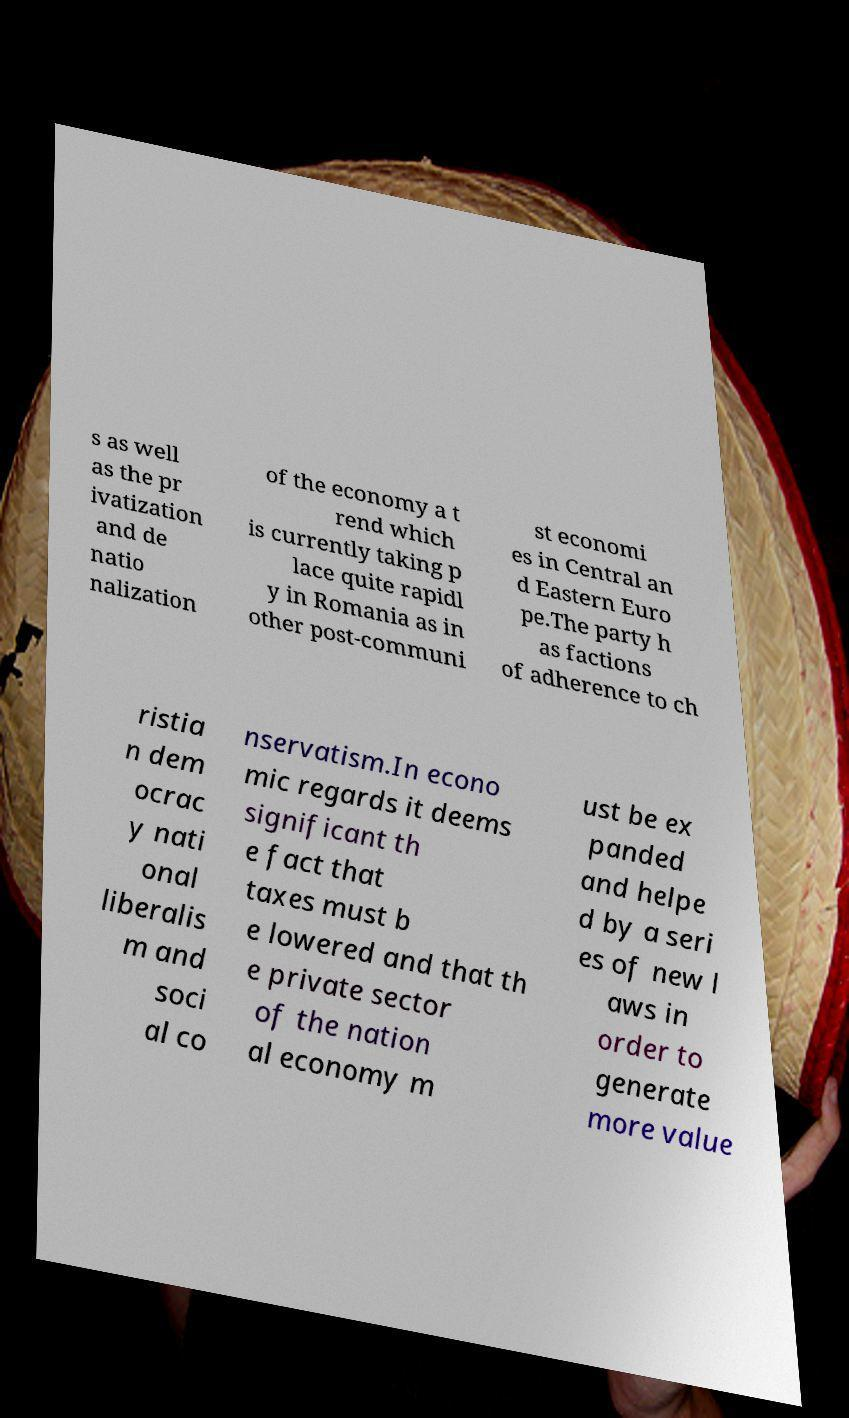Could you extract and type out the text from this image? s as well as the pr ivatization and de natio nalization of the economy a t rend which is currently taking p lace quite rapidl y in Romania as in other post-communi st economi es in Central an d Eastern Euro pe.The party h as factions of adherence to ch ristia n dem ocrac y nati onal liberalis m and soci al co nservatism.In econo mic regards it deems significant th e fact that taxes must b e lowered and that th e private sector of the nation al economy m ust be ex panded and helpe d by a seri es of new l aws in order to generate more value 